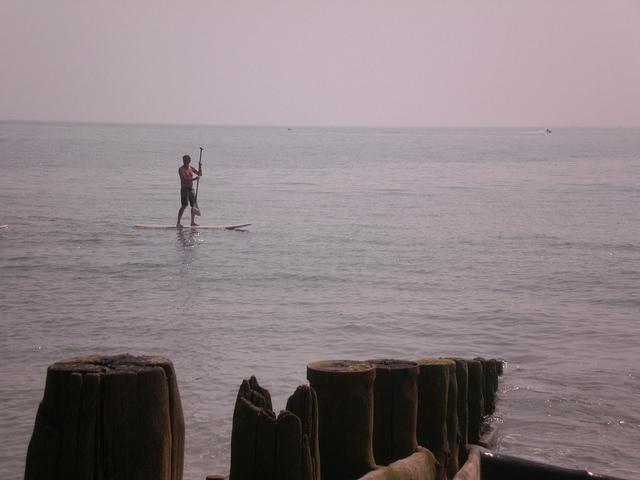How many people are in the photo?
Write a very short answer. 1. Is the man walking on water?
Answer briefly. No. Is the man running away from someone?
Keep it brief. No. How many birds are flying?
Write a very short answer. 0. What sport is this man performing?
Give a very brief answer. Paddle boarding. 